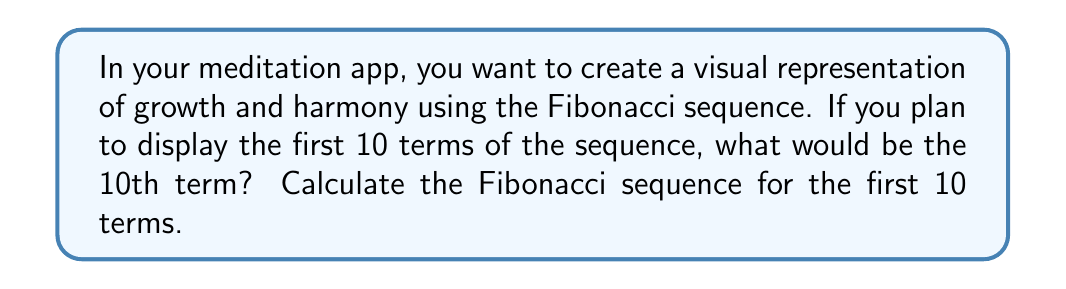Can you solve this math problem? To calculate the Fibonacci sequence for the first 10 terms, we follow these steps:

1. Start with the first two terms of the sequence: $F_1 = 1$ and $F_2 = 1$

2. For each subsequent term, add the two preceding terms:
   $F_n = F_{n-1} + F_{n-2}$ for $n \geq 3$

3. Calculate each term:
   $F_3 = F_2 + F_1 = 1 + 1 = 2$
   $F_4 = F_3 + F_2 = 2 + 1 = 3$
   $F_5 = F_4 + F_3 = 3 + 2 = 5$
   $F_6 = F_5 + F_4 = 5 + 3 = 8$
   $F_7 = F_6 + F_5 = 8 + 5 = 13$
   $F_8 = F_7 + F_6 = 13 + 8 = 21$
   $F_9 = F_8 + F_7 = 21 + 13 = 34$
   $F_{10} = F_9 + F_8 = 34 + 21 = 55$

4. The complete sequence for the first 10 terms is:
   $$1, 1, 2, 3, 5, 8, 13, 21, 34, 55$$

Therefore, the 10th term of the Fibonacci sequence is 55.
Answer: 55 